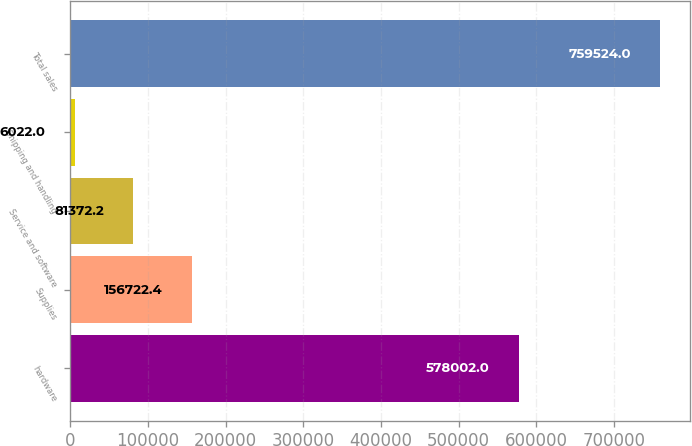Convert chart to OTSL. <chart><loc_0><loc_0><loc_500><loc_500><bar_chart><fcel>hardware<fcel>Supplies<fcel>Service and software<fcel>Shipping and handling<fcel>Total sales<nl><fcel>578002<fcel>156722<fcel>81372.2<fcel>6022<fcel>759524<nl></chart> 